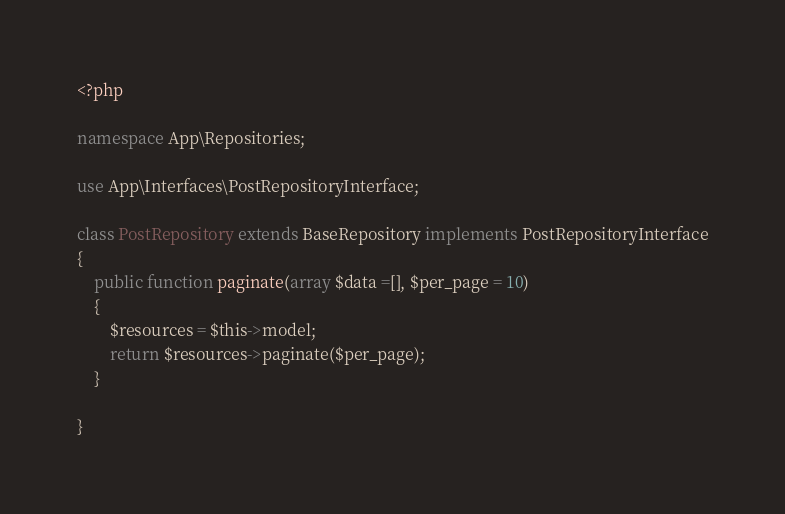<code> <loc_0><loc_0><loc_500><loc_500><_PHP_><?php

namespace App\Repositories;

use App\Interfaces\PostRepositoryInterface;

class PostRepository extends BaseRepository implements PostRepositoryInterface
{
    public function paginate(array $data =[], $per_page = 10)
    {
        $resources = $this->model;
        return $resources->paginate($per_page);
    }

}
</code> 